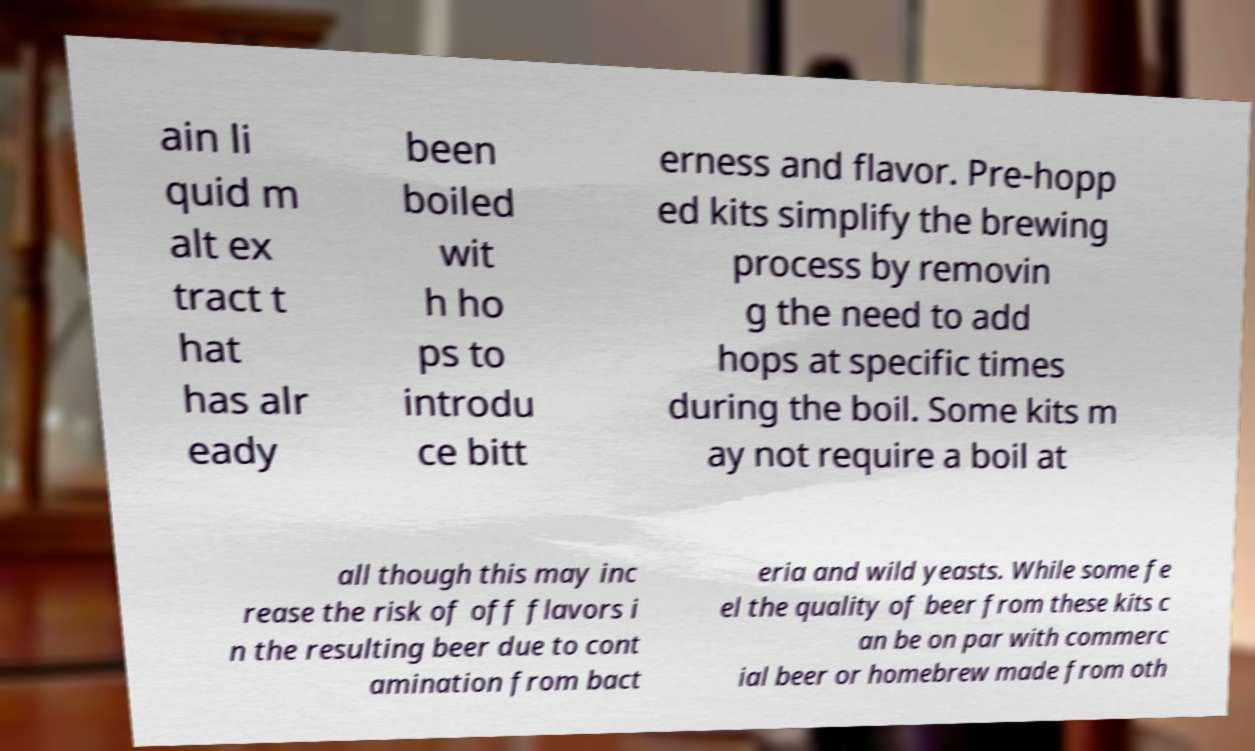Please read and relay the text visible in this image. What does it say? ain li quid m alt ex tract t hat has alr eady been boiled wit h ho ps to introdu ce bitt erness and flavor. Pre-hopp ed kits simplify the brewing process by removin g the need to add hops at specific times during the boil. Some kits m ay not require a boil at all though this may inc rease the risk of off flavors i n the resulting beer due to cont amination from bact eria and wild yeasts. While some fe el the quality of beer from these kits c an be on par with commerc ial beer or homebrew made from oth 